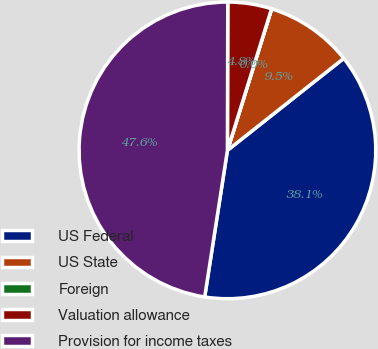Convert chart. <chart><loc_0><loc_0><loc_500><loc_500><pie_chart><fcel>US Federal<fcel>US State<fcel>Foreign<fcel>Valuation allowance<fcel>Provision for income taxes<nl><fcel>38.1%<fcel>9.53%<fcel>0.01%<fcel>4.77%<fcel>47.59%<nl></chart> 